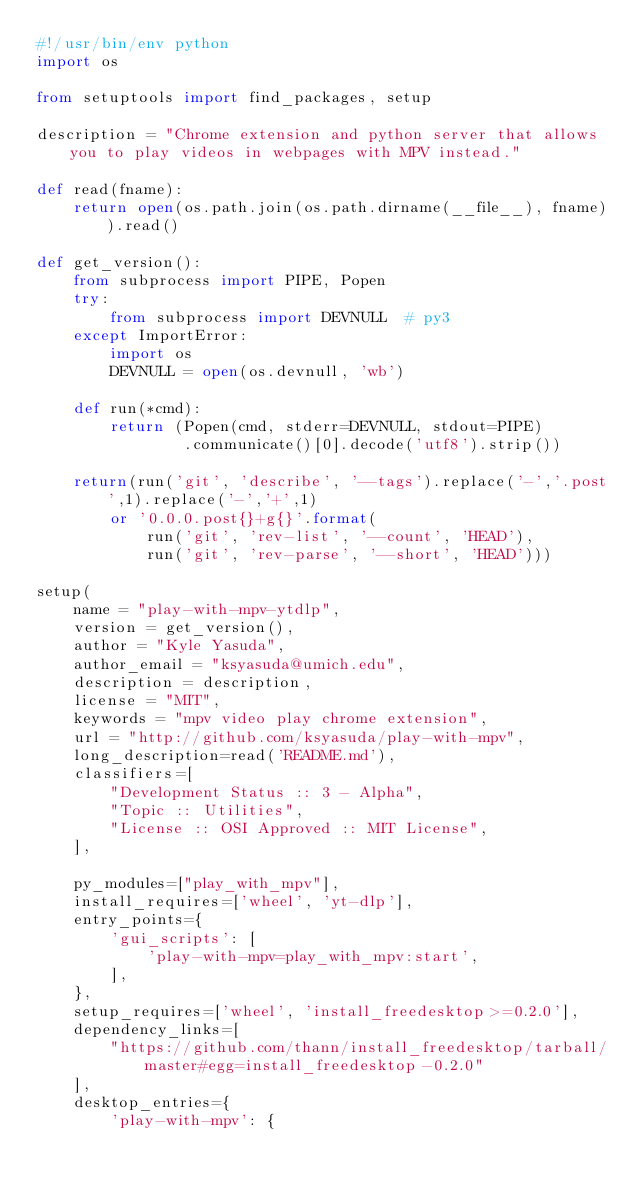<code> <loc_0><loc_0><loc_500><loc_500><_Python_>#!/usr/bin/env python
import os

from setuptools import find_packages, setup

description = "Chrome extension and python server that allows you to play videos in webpages with MPV instead."

def read(fname):
    return open(os.path.join(os.path.dirname(__file__), fname)).read()

def get_version():
    from subprocess import PIPE, Popen
    try:
        from subprocess import DEVNULL  # py3
    except ImportError:
        import os
        DEVNULL = open(os.devnull, 'wb')

    def run(*cmd):
        return (Popen(cmd, stderr=DEVNULL, stdout=PIPE)
                .communicate()[0].decode('utf8').strip())

    return(run('git', 'describe', '--tags').replace('-','.post',1).replace('-','+',1)
        or '0.0.0.post{}+g{}'.format(
            run('git', 'rev-list', '--count', 'HEAD'),
            run('git', 'rev-parse', '--short', 'HEAD')))

setup(
    name = "play-with-mpv-ytdlp",
    version = get_version(),
    author = "Kyle Yasuda",
    author_email = "ksyasuda@umich.edu",
    description = description,
    license = "MIT",
    keywords = "mpv video play chrome extension",
    url = "http://github.com/ksyasuda/play-with-mpv",
    long_description=read('README.md'),
    classifiers=[
        "Development Status :: 3 - Alpha",
        "Topic :: Utilities",
        "License :: OSI Approved :: MIT License",
    ],

    py_modules=["play_with_mpv"],
    install_requires=['wheel', 'yt-dlp'],
    entry_points={
        'gui_scripts': [
            'play-with-mpv=play_with_mpv:start',
        ],
    },
    setup_requires=['wheel', 'install_freedesktop>=0.2.0'],
    dependency_links=[
        "https://github.com/thann/install_freedesktop/tarball/master#egg=install_freedesktop-0.2.0"
    ],
    desktop_entries={
        'play-with-mpv': {</code> 